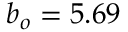<formula> <loc_0><loc_0><loc_500><loc_500>b _ { o } = 5 . 6 9 \AA</formula> 